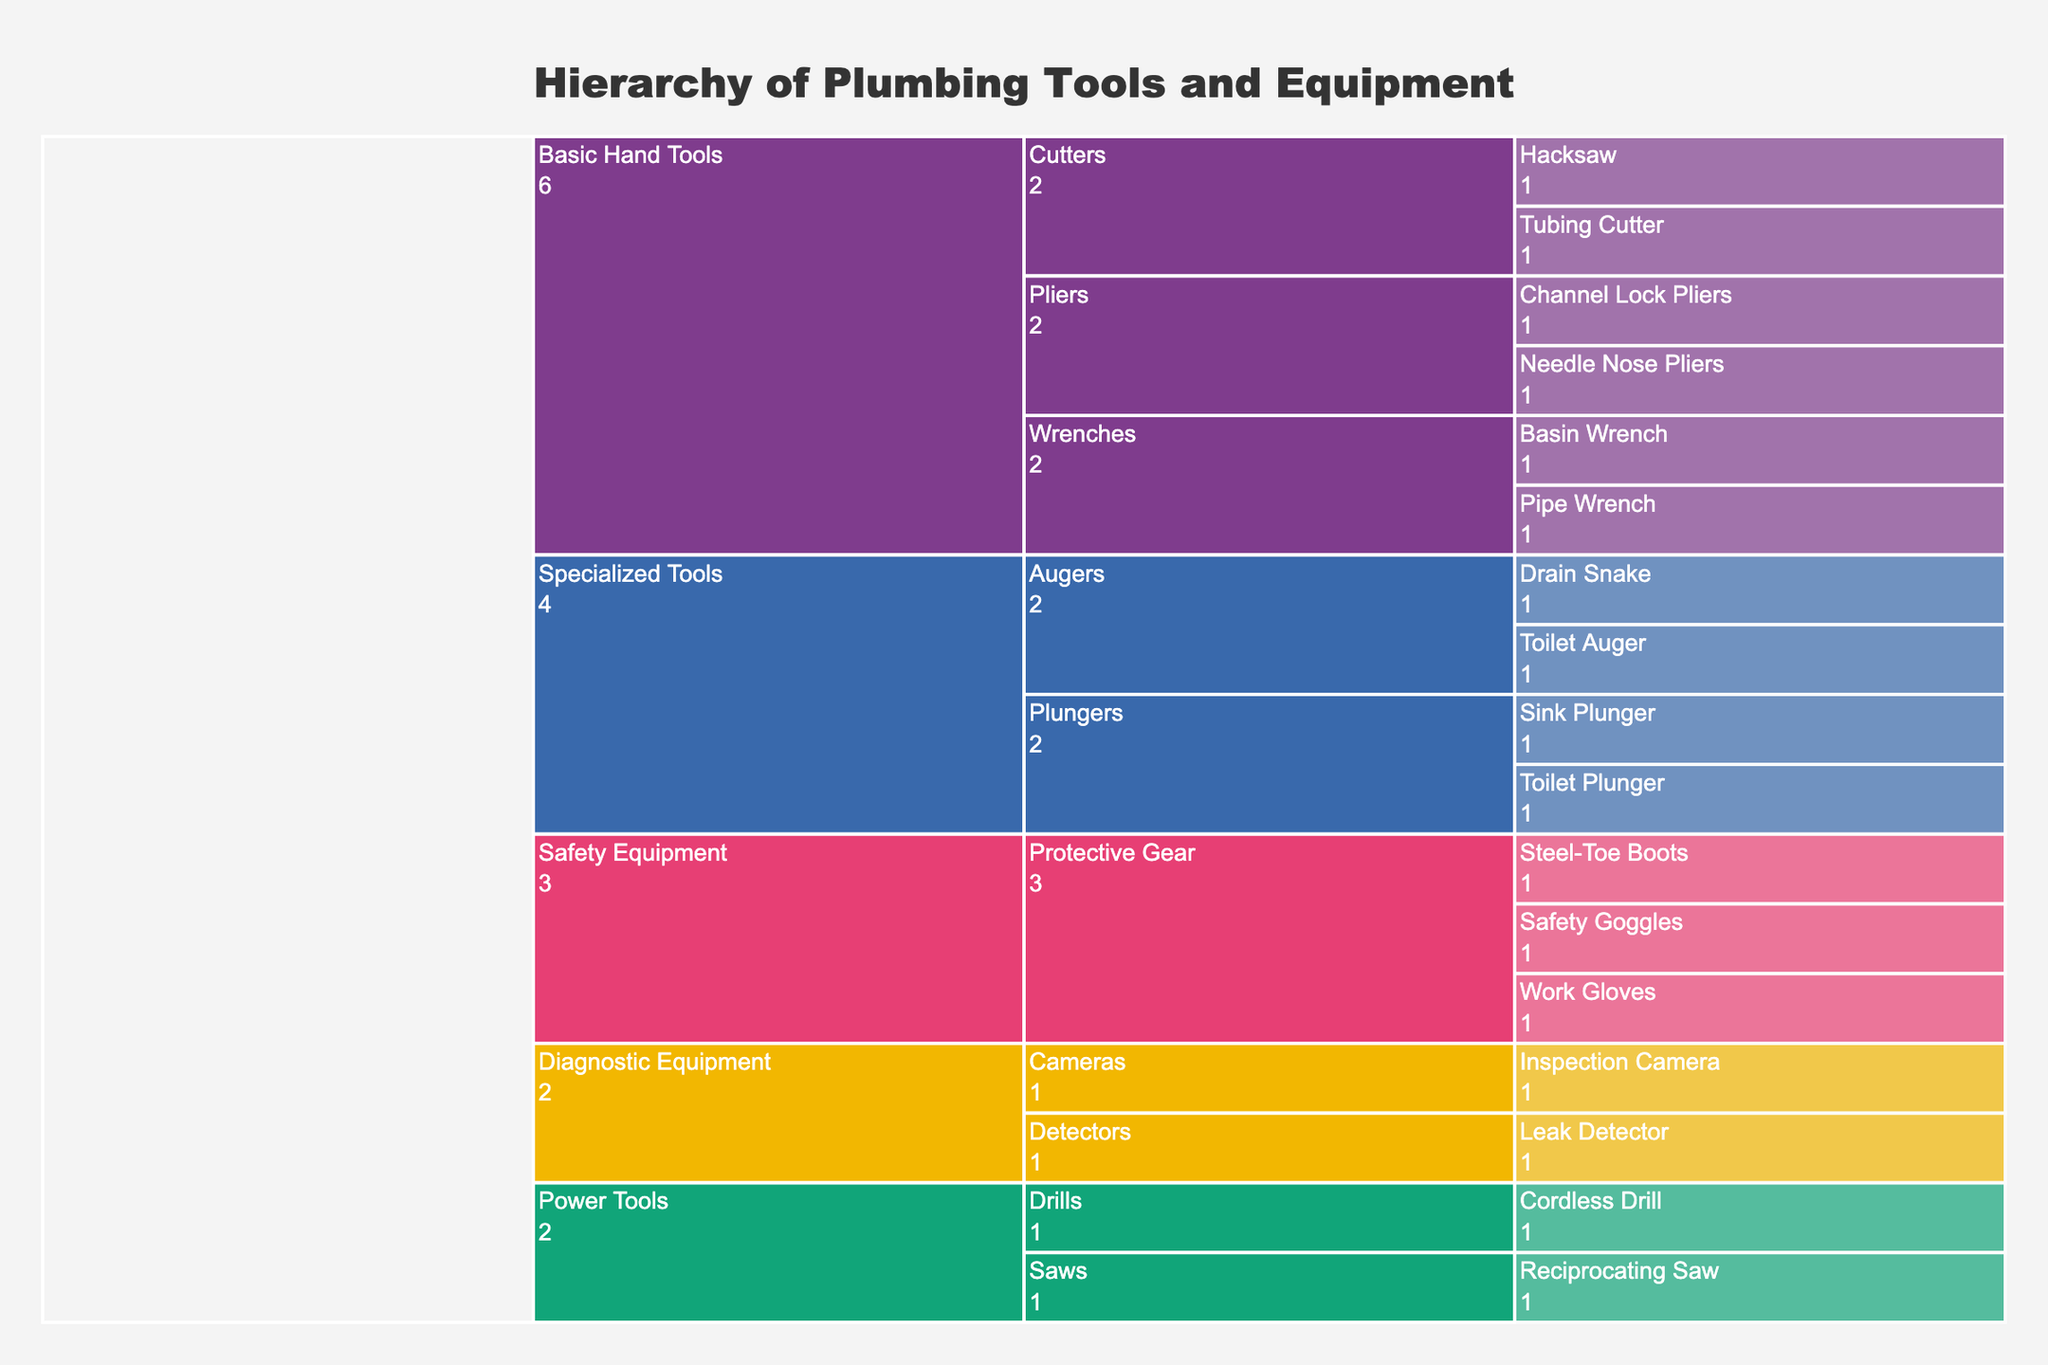What's the title of the chart? The title is usually displayed at the top of the chart and provides a summary of the chart content.
Answer: Hierarchy of Plumbing Tools and Equipment How many categories are there in the chart? Categories are the highest hierarchical level and usually have bold colors. Count the distinct categories in the chart.
Answer: 5 What is the total number of tools in the Basic Hand Tools category? Identify the Basic Hand Tools category, count all the individual tools listed within this category.
Answer: 6 Which category has the most subcategories? Look at the hierarchical paths to determine which category branches out into the highest number of subcategories.
Answer: Safety Equipment How many tools are under the Specialized Tools category? Identify the Specialized Tools category, and count the total number of tools listed under it.
Answer: 4 Which subcategory under Basic Hand Tools has the most tools? Look under the Basic Hand Tools category, then count the number of tools in each subcategory to find the one with the highest count.
Answer: Pliers Compare the number of tools under Safety Equipment and Diagnostic Equipment. Which one has more tools? Count the tools under both Safety Equipment and Diagnostic Equipment categories, then compare the counts.
Answer: Safety Equipment Are there more cutting tools or pliers under Basic Hand Tools? Count the number of tools in the Cutters subcategory and the Pliers subcategory under Basic Hand Tools, then compare the counts.
Answer: Cutters What is the only subcategory under Power Tools? Identify the Power Tools category and see the distinct subcategory listed under it.
Answer: Drills Which subcategory has exactly two tools listed under it? Go through each subcategory and count the number of tools, identify the one with exactly two tools.
Answer: Plungers 